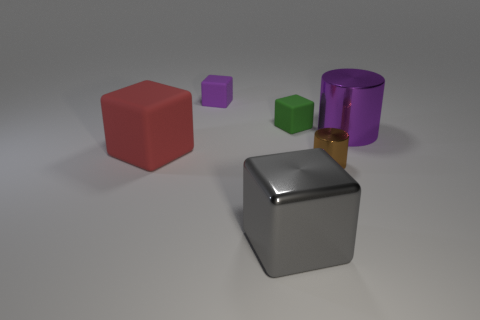Is there a matte cube of the same color as the large shiny cylinder?
Your answer should be very brief. Yes. There is a small rubber thing behind the green cube; is it the same color as the big cylinder?
Provide a short and direct response. Yes. The big object that is both on the left side of the small brown metallic cylinder and behind the gray block has what shape?
Offer a terse response. Cube. What material is the big object that is both on the right side of the big matte block and in front of the large metal cylinder?
Your answer should be very brief. Metal. What is the shape of the big purple thing that is the same material as the small brown cylinder?
Provide a succinct answer. Cylinder. Is there anything else that is the same color as the big cylinder?
Offer a terse response. Yes. Is the number of metallic cylinders that are in front of the tiny brown metal thing greater than the number of big rubber things?
Provide a short and direct response. No. What material is the small brown cylinder?
Your response must be concise. Metal. How many gray things have the same size as the brown object?
Offer a terse response. 0. Is the number of red rubber things right of the small brown metallic object the same as the number of metal cylinders that are behind the gray metal block?
Give a very brief answer. No. 